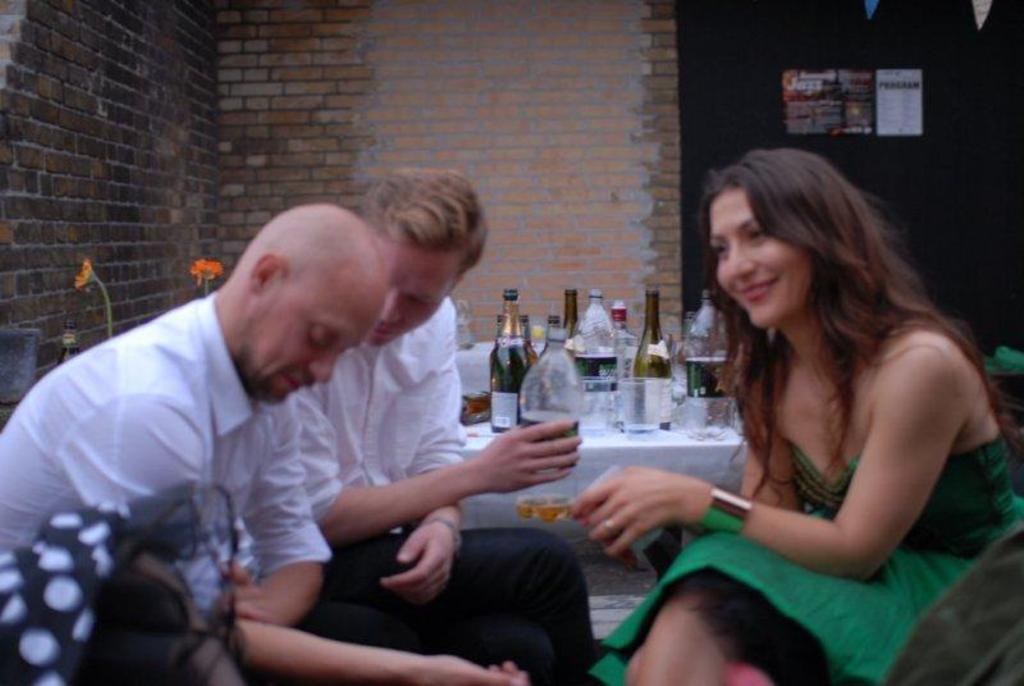In one or two sentences, can you explain what this image depicts? In this image we can see three persons sitting on the chairs in which one of them is holding a glass with some drink, behind them, we can see a table with a few bottles and glasses, there we can see flowers, wall and some posters attached to the wall, in front of them we can a black color object. 